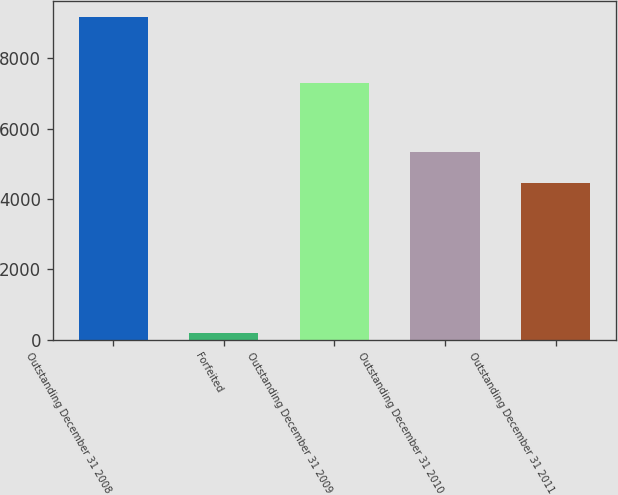Convert chart. <chart><loc_0><loc_0><loc_500><loc_500><bar_chart><fcel>Outstanding December 31 2008<fcel>Forfeited<fcel>Outstanding December 31 2009<fcel>Outstanding December 31 2010<fcel>Outstanding December 31 2011<nl><fcel>9178<fcel>189<fcel>7289<fcel>5348.9<fcel>4450<nl></chart> 